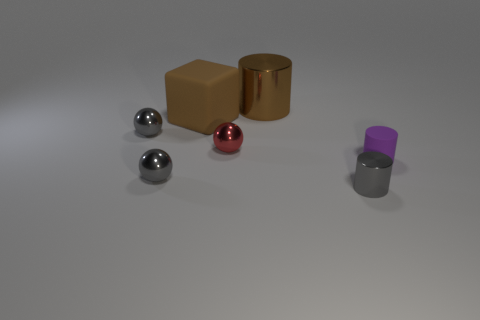Add 1 tiny cyan matte cylinders. How many objects exist? 8 Subtract all cylinders. How many objects are left? 4 Add 4 gray metallic objects. How many gray metallic objects are left? 7 Add 6 tiny purple rubber cubes. How many tiny purple rubber cubes exist? 6 Subtract 0 cyan blocks. How many objects are left? 7 Subtract all small purple matte spheres. Subtract all large cylinders. How many objects are left? 6 